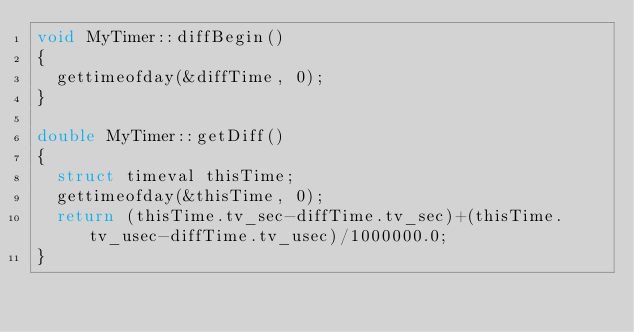<code> <loc_0><loc_0><loc_500><loc_500><_C++_>void MyTimer::diffBegin()
{
	gettimeofday(&diffTime, 0);
}

double MyTimer::getDiff()
{
	struct timeval thisTime;
	gettimeofday(&thisTime, 0);
	return (thisTime.tv_sec-diffTime.tv_sec)+(thisTime.tv_usec-diffTime.tv_usec)/1000000.0;
}

</code> 